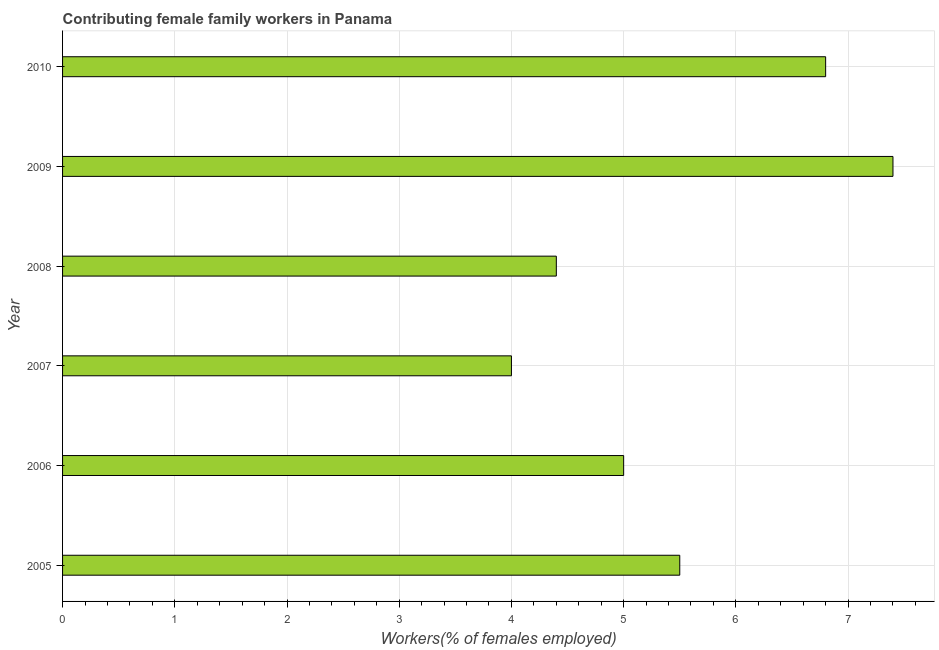Does the graph contain grids?
Ensure brevity in your answer.  Yes. What is the title of the graph?
Your response must be concise. Contributing female family workers in Panama. What is the label or title of the X-axis?
Make the answer very short. Workers(% of females employed). What is the label or title of the Y-axis?
Provide a short and direct response. Year. What is the contributing female family workers in 2008?
Make the answer very short. 4.4. Across all years, what is the maximum contributing female family workers?
Your answer should be very brief. 7.4. In which year was the contributing female family workers maximum?
Your response must be concise. 2009. What is the sum of the contributing female family workers?
Ensure brevity in your answer.  33.1. What is the average contributing female family workers per year?
Offer a terse response. 5.52. What is the median contributing female family workers?
Give a very brief answer. 5.25. What is the ratio of the contributing female family workers in 2009 to that in 2010?
Give a very brief answer. 1.09. Is the contributing female family workers in 2005 less than that in 2009?
Provide a short and direct response. Yes. What is the difference between the highest and the second highest contributing female family workers?
Your response must be concise. 0.6. Is the sum of the contributing female family workers in 2006 and 2010 greater than the maximum contributing female family workers across all years?
Keep it short and to the point. Yes. In how many years, is the contributing female family workers greater than the average contributing female family workers taken over all years?
Offer a terse response. 2. How many bars are there?
Offer a very short reply. 6. Are all the bars in the graph horizontal?
Offer a very short reply. Yes. How many years are there in the graph?
Provide a succinct answer. 6. What is the difference between two consecutive major ticks on the X-axis?
Provide a succinct answer. 1. What is the Workers(% of females employed) in 2005?
Make the answer very short. 5.5. What is the Workers(% of females employed) in 2006?
Provide a succinct answer. 5. What is the Workers(% of females employed) in 2008?
Provide a succinct answer. 4.4. What is the Workers(% of females employed) of 2009?
Offer a very short reply. 7.4. What is the Workers(% of females employed) in 2010?
Give a very brief answer. 6.8. What is the difference between the Workers(% of females employed) in 2005 and 2006?
Your answer should be very brief. 0.5. What is the difference between the Workers(% of females employed) in 2005 and 2008?
Keep it short and to the point. 1.1. What is the difference between the Workers(% of females employed) in 2006 and 2007?
Keep it short and to the point. 1. What is the difference between the Workers(% of females employed) in 2006 and 2008?
Offer a terse response. 0.6. What is the difference between the Workers(% of females employed) in 2007 and 2008?
Offer a terse response. -0.4. What is the difference between the Workers(% of females employed) in 2008 and 2010?
Give a very brief answer. -2.4. What is the ratio of the Workers(% of females employed) in 2005 to that in 2006?
Keep it short and to the point. 1.1. What is the ratio of the Workers(% of females employed) in 2005 to that in 2007?
Keep it short and to the point. 1.38. What is the ratio of the Workers(% of females employed) in 2005 to that in 2009?
Offer a terse response. 0.74. What is the ratio of the Workers(% of females employed) in 2005 to that in 2010?
Keep it short and to the point. 0.81. What is the ratio of the Workers(% of females employed) in 2006 to that in 2008?
Offer a very short reply. 1.14. What is the ratio of the Workers(% of females employed) in 2006 to that in 2009?
Your response must be concise. 0.68. What is the ratio of the Workers(% of females employed) in 2006 to that in 2010?
Give a very brief answer. 0.73. What is the ratio of the Workers(% of females employed) in 2007 to that in 2008?
Ensure brevity in your answer.  0.91. What is the ratio of the Workers(% of females employed) in 2007 to that in 2009?
Your response must be concise. 0.54. What is the ratio of the Workers(% of females employed) in 2007 to that in 2010?
Offer a terse response. 0.59. What is the ratio of the Workers(% of females employed) in 2008 to that in 2009?
Your answer should be compact. 0.59. What is the ratio of the Workers(% of females employed) in 2008 to that in 2010?
Offer a very short reply. 0.65. What is the ratio of the Workers(% of females employed) in 2009 to that in 2010?
Offer a terse response. 1.09. 